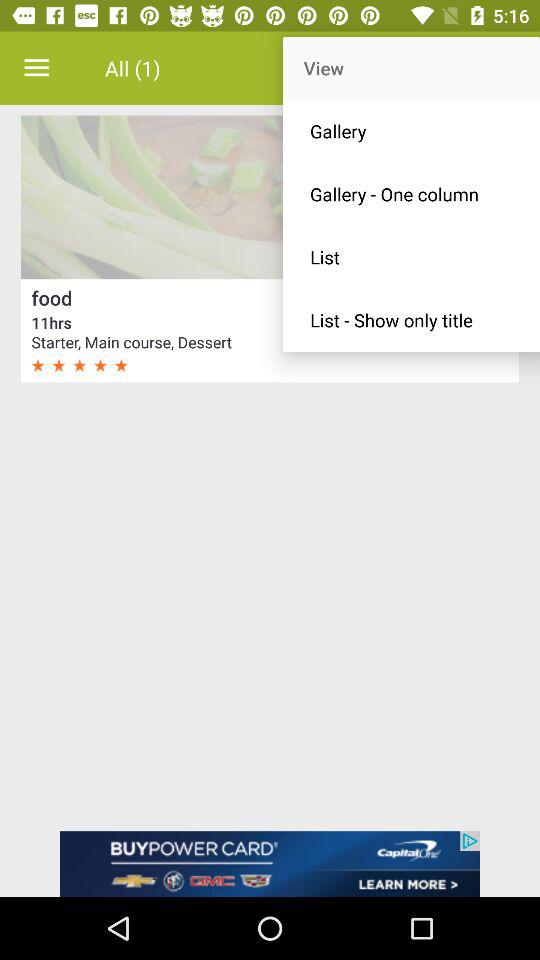What is the duration given in the food menu? The duration given in the food menu is 11 hours. 